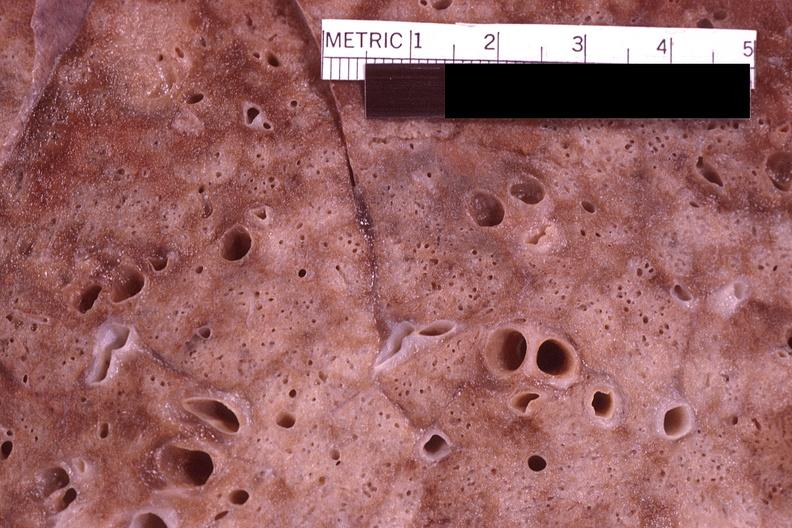s respiratory present?
Answer the question using a single word or phrase. Yes 